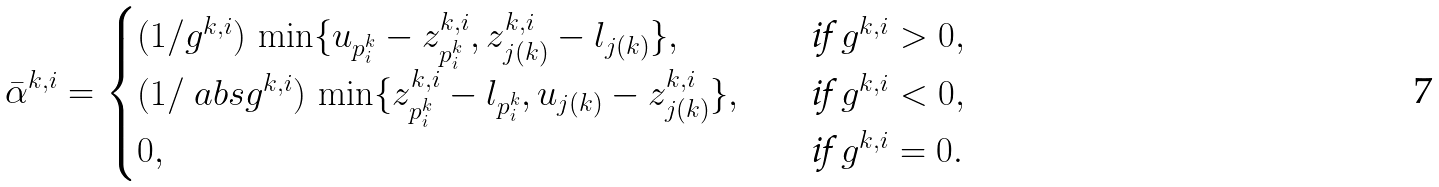<formula> <loc_0><loc_0><loc_500><loc_500>\bar { \alpha } ^ { k , i } = \begin{cases} ( 1 / g ^ { k , i } ) \, \min \{ u _ { p ^ { k } _ { i } } - z ^ { k , i } _ { p ^ { k } _ { i } } , z ^ { k , i } _ { j ( k ) } - l _ { j ( k ) } \} , \quad & \text {if } g ^ { k , i } > 0 , \\ ( 1 / \ a b s { g ^ { k , i } } ) \, \min \{ z ^ { k , i } _ { p ^ { k } _ { i } } - l _ { p ^ { k } _ { i } } , u _ { j ( k ) } - z ^ { k , i } _ { j ( k ) } \} , \quad & \text {if } g ^ { k , i } < 0 , \\ 0 , & \text {if } g ^ { k , i } = 0 . \end{cases}</formula> 